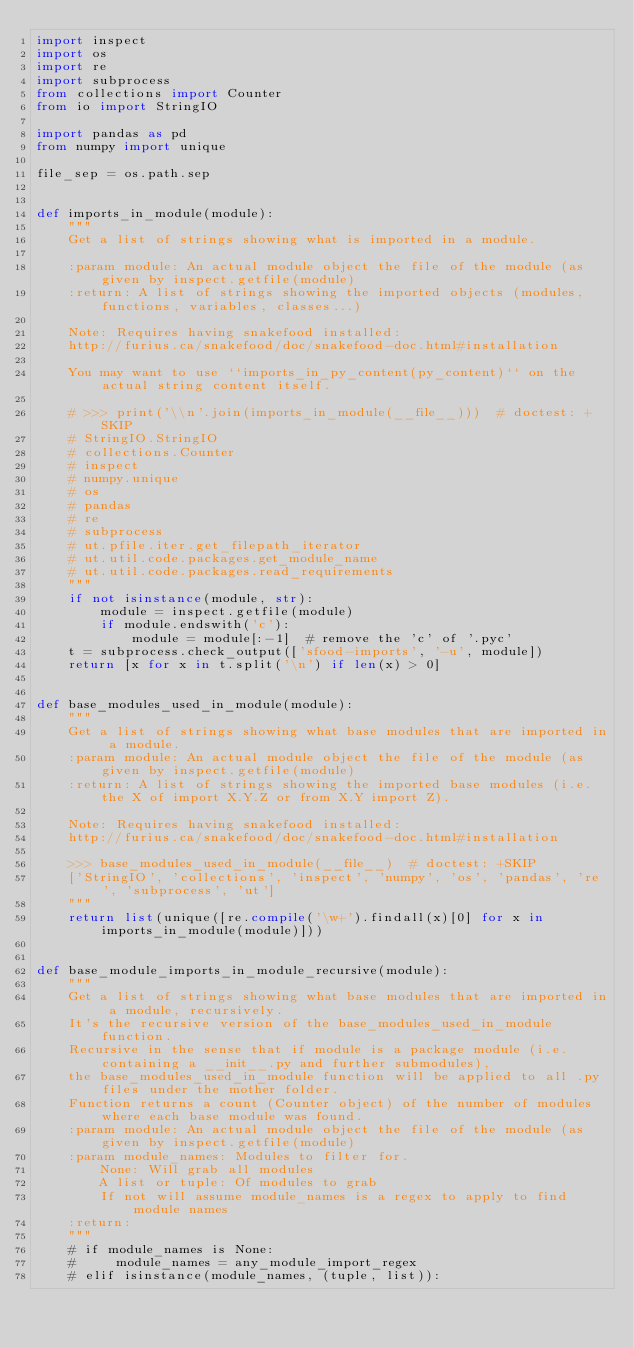<code> <loc_0><loc_0><loc_500><loc_500><_Python_>import inspect
import os
import re
import subprocess
from collections import Counter
from io import StringIO

import pandas as pd
from numpy import unique

file_sep = os.path.sep


def imports_in_module(module):
    """
    Get a list of strings showing what is imported in a module.

    :param module: An actual module object the file of the module (as given by inspect.getfile(module)
    :return: A list of strings showing the imported objects (modules, functions, variables, classes...)

    Note: Requires having snakefood installed:
    http://furius.ca/snakefood/doc/snakefood-doc.html#installation

    You may want to use ``imports_in_py_content(py_content)`` on the actual string content itself.

    # >>> print('\\n'.join(imports_in_module(__file__)))  # doctest: +SKIP
    # StringIO.StringIO
    # collections.Counter
    # inspect
    # numpy.unique
    # os
    # pandas
    # re
    # subprocess
    # ut.pfile.iter.get_filepath_iterator
    # ut.util.code.packages.get_module_name
    # ut.util.code.packages.read_requirements
    """
    if not isinstance(module, str):
        module = inspect.getfile(module)
        if module.endswith('c'):
            module = module[:-1]  # remove the 'c' of '.pyc'
    t = subprocess.check_output(['sfood-imports', '-u', module])
    return [x for x in t.split('\n') if len(x) > 0]


def base_modules_used_in_module(module):
    """
    Get a list of strings showing what base modules that are imported in a module.
    :param module: An actual module object the file of the module (as given by inspect.getfile(module)
    :return: A list of strings showing the imported base modules (i.e. the X of import X.Y.Z or from X.Y import Z).

    Note: Requires having snakefood installed:
    http://furius.ca/snakefood/doc/snakefood-doc.html#installation

    >>> base_modules_used_in_module(__file__)  # doctest: +SKIP
    ['StringIO', 'collections', 'inspect', 'numpy', 'os', 'pandas', 're', 'subprocess', 'ut']
    """
    return list(unique([re.compile('\w+').findall(x)[0] for x in imports_in_module(module)]))


def base_module_imports_in_module_recursive(module):
    """
    Get a list of strings showing what base modules that are imported in a module, recursively.
    It's the recursive version of the base_modules_used_in_module function.
    Recursive in the sense that if module is a package module (i.e. containing a __init__.py and further submodules),
    the base_modules_used_in_module function will be applied to all .py files under the mother folder.
    Function returns a count (Counter object) of the number of modules where each base module was found.
    :param module: An actual module object the file of the module (as given by inspect.getfile(module)
    :param module_names: Modules to filter for.
        None: Will grab all modules
        A list or tuple: Of modules to grab
        If not will assume module_names is a regex to apply to find module names
    :return:
    """
    # if module_names is None:
    #     module_names = any_module_import_regex
    # elif isinstance(module_names, (tuple, list)):</code> 